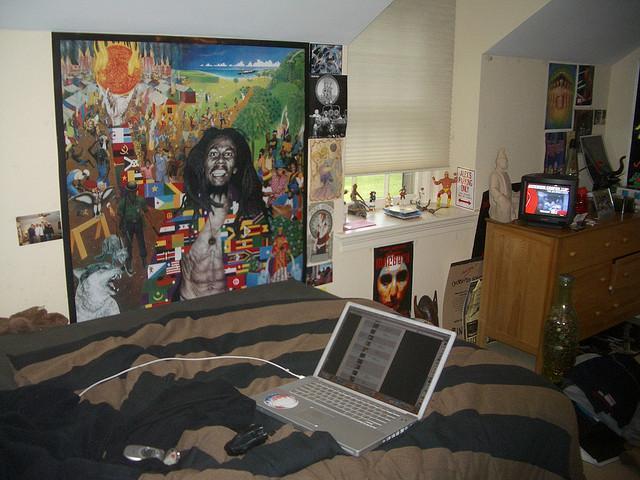How many cats are in the image?
Give a very brief answer. 0. How many laptops are on the bed?
Give a very brief answer. 1. How many bottles are there?
Give a very brief answer. 1. 